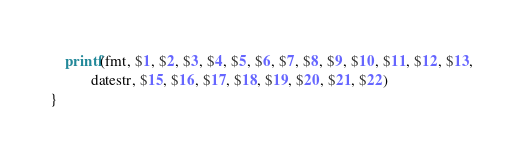<code> <loc_0><loc_0><loc_500><loc_500><_Awk_>    printf(fmt, $1, $2, $3, $4, $5, $6, $7, $8, $9, $10, $11, $12, $13,
           datestr, $15, $16, $17, $18, $19, $20, $21, $22)
}
</code> 